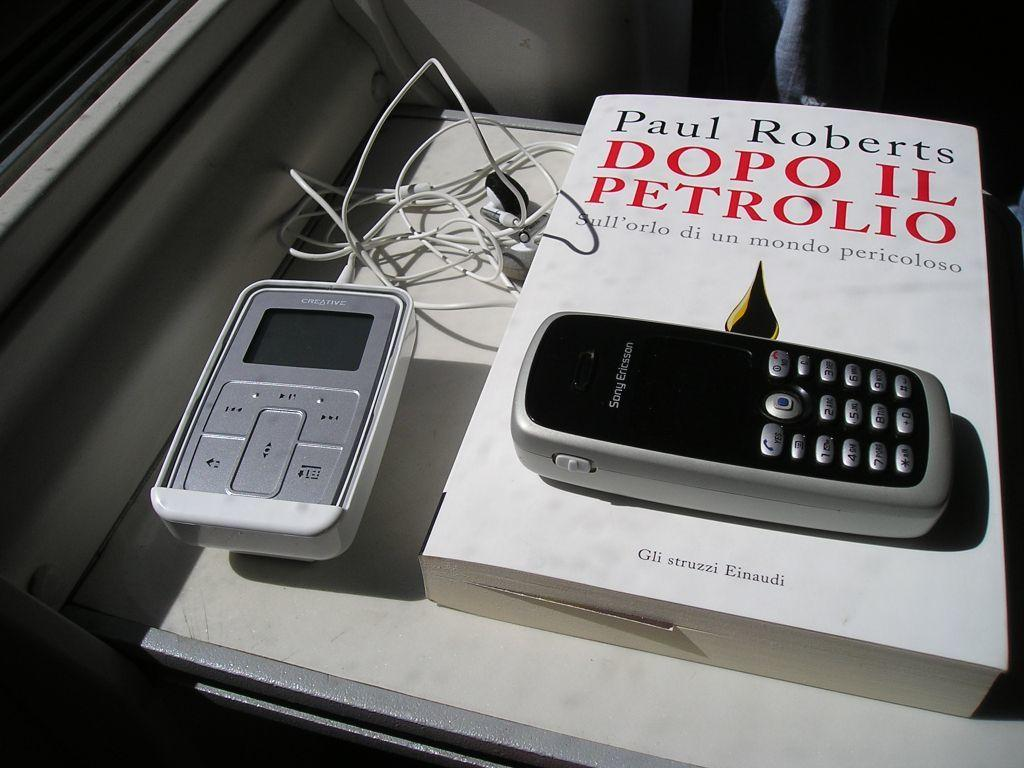<image>
Render a clear and concise summary of the photo. An old Sony Ericsson phone sits on top of a book called Dopo Il Petrolio by Paul Roberts 